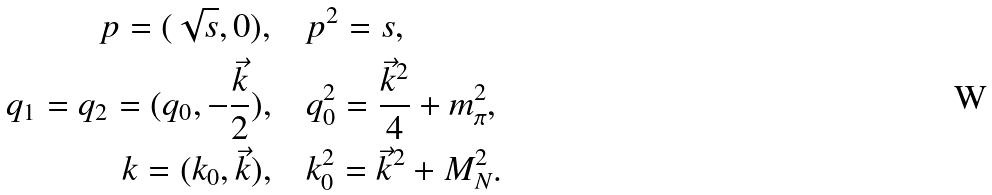<formula> <loc_0><loc_0><loc_500><loc_500>p = ( \sqrt { s } , 0 ) , & \quad p ^ { 2 } = s , \\ q _ { 1 } = q _ { 2 } = ( q _ { 0 } , - \frac { \vec { k } } { 2 } ) , & \quad q _ { 0 } ^ { 2 } = \frac { \vec { k } ^ { 2 } } { 4 } + m ^ { 2 } _ { \pi } , \\ k = ( k _ { 0 } , \vec { k } ) , & \quad k _ { 0 } ^ { 2 } = \vec { k } ^ { 2 } + M _ { N } ^ { 2 } .</formula> 